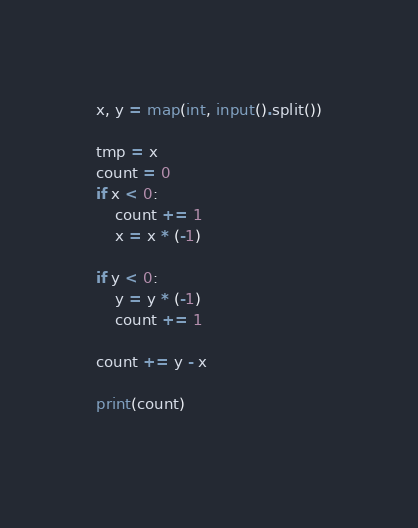Convert code to text. <code><loc_0><loc_0><loc_500><loc_500><_Python_>x, y = map(int, input().split())

tmp = x
count = 0
if x < 0:
    count += 1
    x = x * (-1)
    
if y < 0:
    y = y * (-1)
    count += 1
    
count += y - x
    
print(count)
    </code> 